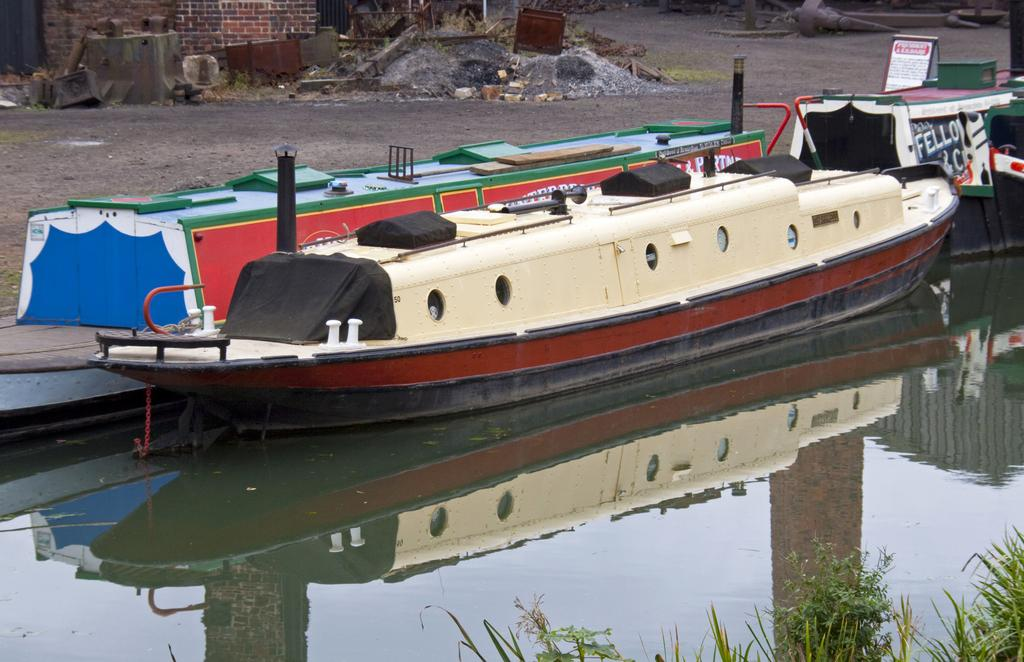What is floating on the water in the image? There are boats floating on the water in the image. What can be seen in the bottom right corner of the image? There are plants in the bottom right of the image. What is located in the top left of the image? There is a wall in the top left of the image. What is the tax rate for the boats in the image? There is no information about tax rates in the image, as it only shows boats floating on the water. What is the aftermath of the storm in the image? There is no mention of a storm or any aftermath in the image; it only shows boats floating on the water and plants in the bottom right corner. 